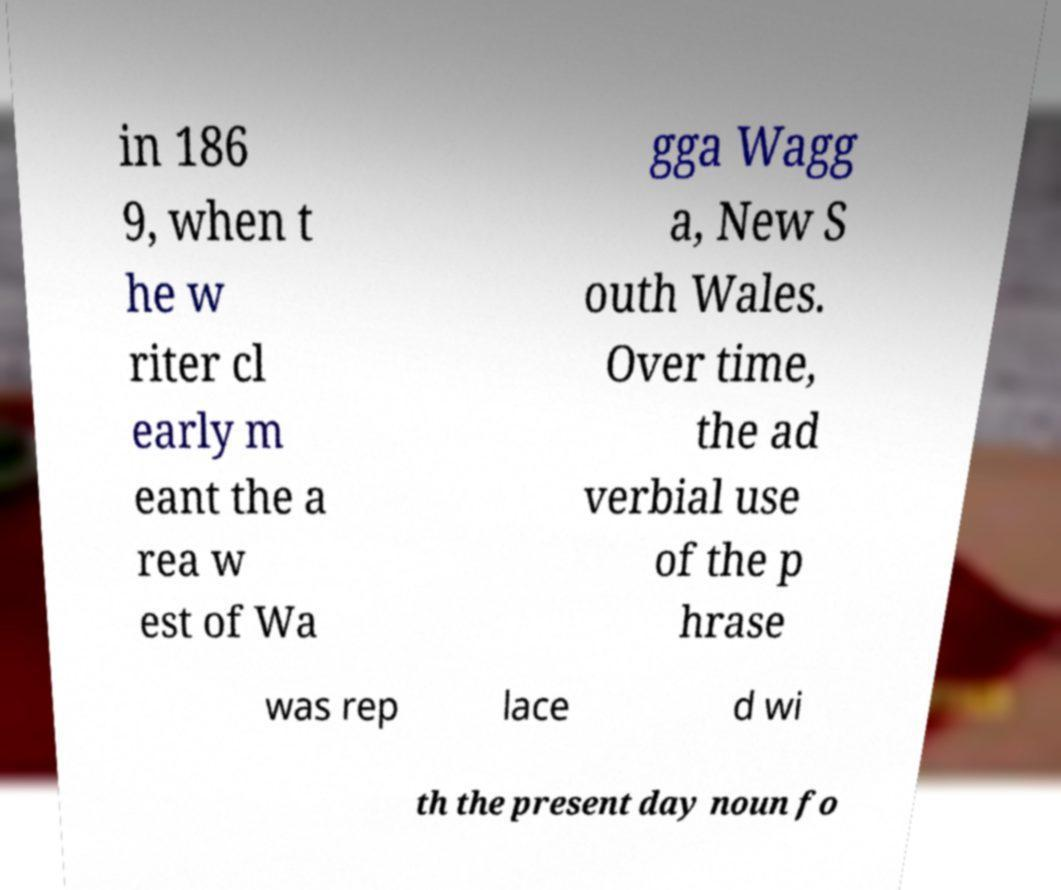What messages or text are displayed in this image? I need them in a readable, typed format. in 186 9, when t he w riter cl early m eant the a rea w est of Wa gga Wagg a, New S outh Wales. Over time, the ad verbial use of the p hrase was rep lace d wi th the present day noun fo 